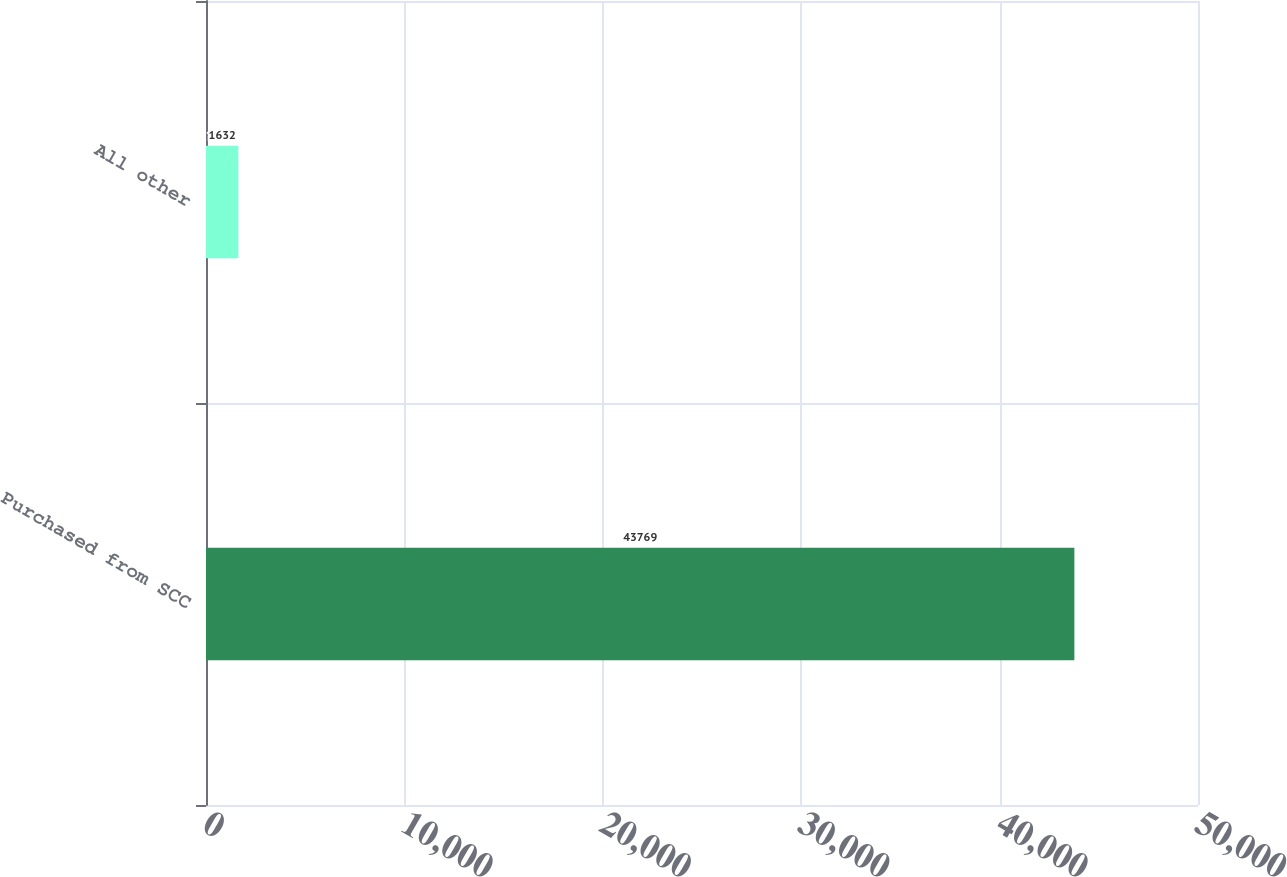Convert chart. <chart><loc_0><loc_0><loc_500><loc_500><bar_chart><fcel>Purchased from SCC<fcel>All other<nl><fcel>43769<fcel>1632<nl></chart> 